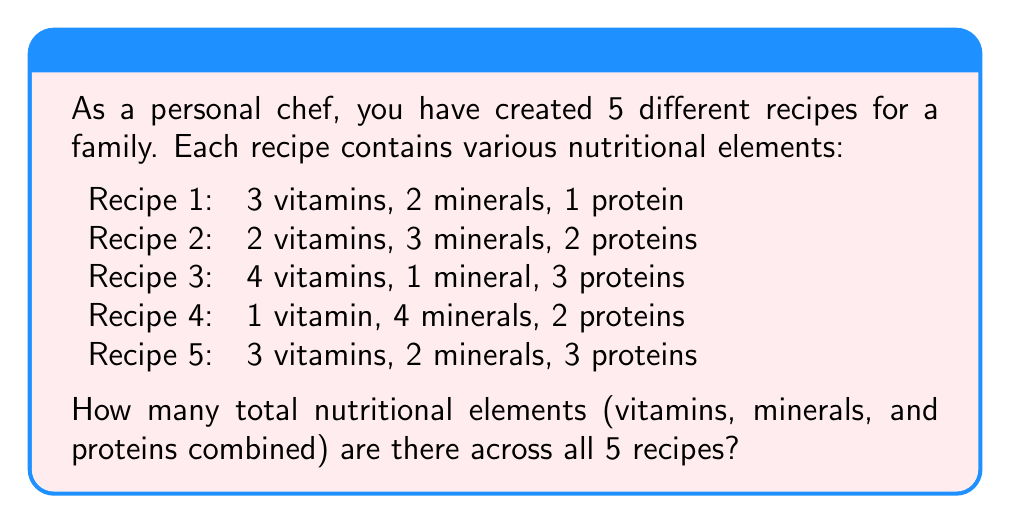Solve this math problem. To solve this problem, we need to sum up all the nutritional elements across the 5 recipes. Let's break it down step by step:

1. Count the elements in each recipe:
   Recipe 1: $3 + 2 + 1 = 6$
   Recipe 2: $2 + 3 + 2 = 7$
   Recipe 3: $4 + 1 + 3 = 8$
   Recipe 4: $1 + 4 + 2 = 7$
   Recipe 5: $3 + 2 + 3 = 8$

2. Sum up the totals from each recipe:
   $$\text{Total} = 6 + 7 + 8 + 7 + 8$$

3. Perform the addition:
   $$\text{Total} = 36$$

Therefore, there are 36 total nutritional elements across all 5 recipes.
Answer: 36 nutritional elements 